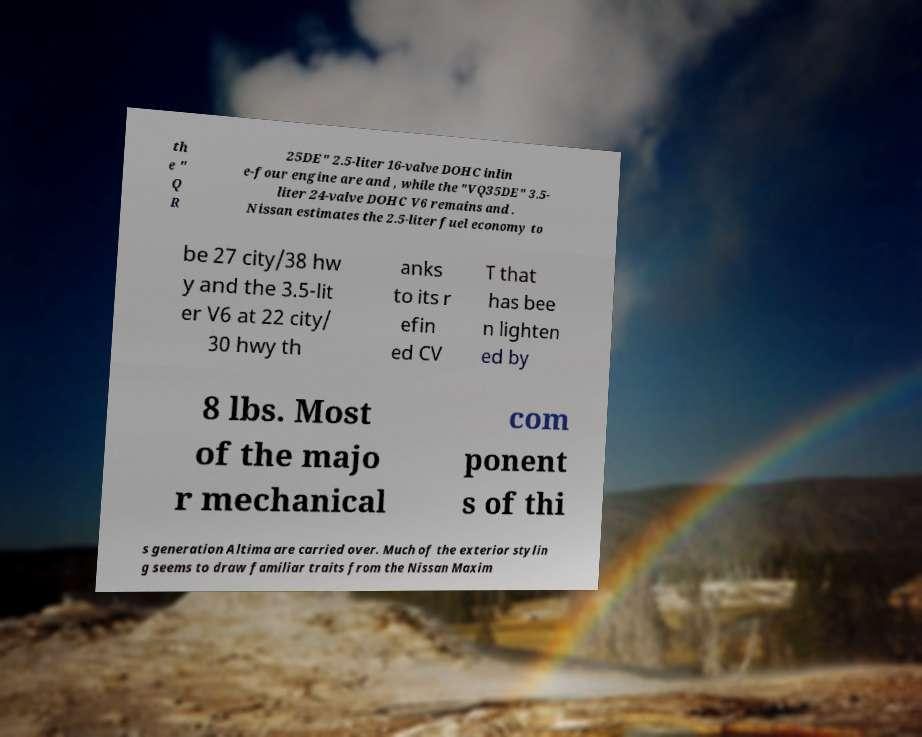Please read and relay the text visible in this image. What does it say? th e " Q R 25DE" 2.5-liter 16-valve DOHC inlin e-four engine are and , while the "VQ35DE" 3.5- liter 24-valve DOHC V6 remains and . Nissan estimates the 2.5-liter fuel economy to be 27 city/38 hw y and the 3.5-lit er V6 at 22 city/ 30 hwy th anks to its r efin ed CV T that has bee n lighten ed by 8 lbs. Most of the majo r mechanical com ponent s of thi s generation Altima are carried over. Much of the exterior stylin g seems to draw familiar traits from the Nissan Maxim 